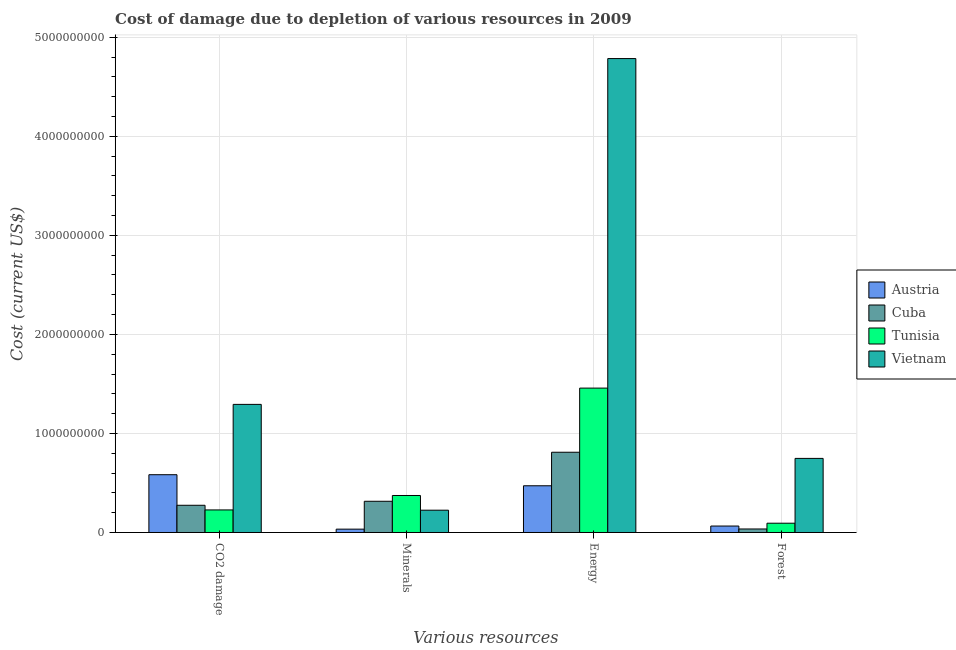How many different coloured bars are there?
Your answer should be compact. 4. Are the number of bars on each tick of the X-axis equal?
Your response must be concise. Yes. How many bars are there on the 3rd tick from the right?
Provide a short and direct response. 4. What is the label of the 3rd group of bars from the left?
Make the answer very short. Energy. What is the cost of damage due to depletion of energy in Cuba?
Your answer should be very brief. 8.10e+08. Across all countries, what is the maximum cost of damage due to depletion of energy?
Offer a terse response. 4.79e+09. Across all countries, what is the minimum cost of damage due to depletion of coal?
Your response must be concise. 2.28e+08. In which country was the cost of damage due to depletion of minerals maximum?
Provide a short and direct response. Tunisia. What is the total cost of damage due to depletion of coal in the graph?
Your response must be concise. 2.38e+09. What is the difference between the cost of damage due to depletion of energy in Cuba and that in Austria?
Make the answer very short. 3.39e+08. What is the difference between the cost of damage due to depletion of coal in Tunisia and the cost of damage due to depletion of energy in Cuba?
Offer a terse response. -5.82e+08. What is the average cost of damage due to depletion of minerals per country?
Ensure brevity in your answer.  2.37e+08. What is the difference between the cost of damage due to depletion of forests and cost of damage due to depletion of energy in Cuba?
Offer a very short reply. -7.75e+08. What is the ratio of the cost of damage due to depletion of coal in Tunisia to that in Austria?
Your answer should be compact. 0.39. Is the difference between the cost of damage due to depletion of energy in Vietnam and Tunisia greater than the difference between the cost of damage due to depletion of forests in Vietnam and Tunisia?
Ensure brevity in your answer.  Yes. What is the difference between the highest and the second highest cost of damage due to depletion of minerals?
Your answer should be very brief. 5.83e+07. What is the difference between the highest and the lowest cost of damage due to depletion of coal?
Provide a short and direct response. 1.07e+09. Is it the case that in every country, the sum of the cost of damage due to depletion of energy and cost of damage due to depletion of forests is greater than the sum of cost of damage due to depletion of minerals and cost of damage due to depletion of coal?
Ensure brevity in your answer.  No. What does the 1st bar from the left in Forest represents?
Your answer should be compact. Austria. What does the 2nd bar from the right in Energy represents?
Provide a succinct answer. Tunisia. How many bars are there?
Ensure brevity in your answer.  16. Are the values on the major ticks of Y-axis written in scientific E-notation?
Ensure brevity in your answer.  No. Does the graph contain any zero values?
Ensure brevity in your answer.  No. Does the graph contain grids?
Your answer should be compact. Yes. How many legend labels are there?
Keep it short and to the point. 4. What is the title of the graph?
Make the answer very short. Cost of damage due to depletion of various resources in 2009 . What is the label or title of the X-axis?
Provide a short and direct response. Various resources. What is the label or title of the Y-axis?
Your answer should be very brief. Cost (current US$). What is the Cost (current US$) of Austria in CO2 damage?
Make the answer very short. 5.83e+08. What is the Cost (current US$) of Cuba in CO2 damage?
Provide a succinct answer. 2.75e+08. What is the Cost (current US$) in Tunisia in CO2 damage?
Give a very brief answer. 2.28e+08. What is the Cost (current US$) of Vietnam in CO2 damage?
Keep it short and to the point. 1.29e+09. What is the Cost (current US$) of Austria in Minerals?
Make the answer very short. 3.38e+07. What is the Cost (current US$) of Cuba in Minerals?
Provide a short and direct response. 3.15e+08. What is the Cost (current US$) in Tunisia in Minerals?
Provide a succinct answer. 3.73e+08. What is the Cost (current US$) in Vietnam in Minerals?
Provide a short and direct response. 2.25e+08. What is the Cost (current US$) of Austria in Energy?
Keep it short and to the point. 4.72e+08. What is the Cost (current US$) of Cuba in Energy?
Keep it short and to the point. 8.10e+08. What is the Cost (current US$) in Tunisia in Energy?
Offer a very short reply. 1.46e+09. What is the Cost (current US$) of Vietnam in Energy?
Make the answer very short. 4.79e+09. What is the Cost (current US$) in Austria in Forest?
Offer a terse response. 6.51e+07. What is the Cost (current US$) of Cuba in Forest?
Provide a short and direct response. 3.54e+07. What is the Cost (current US$) in Tunisia in Forest?
Your answer should be very brief. 9.37e+07. What is the Cost (current US$) of Vietnam in Forest?
Provide a succinct answer. 7.48e+08. Across all Various resources, what is the maximum Cost (current US$) in Austria?
Give a very brief answer. 5.83e+08. Across all Various resources, what is the maximum Cost (current US$) in Cuba?
Your response must be concise. 8.10e+08. Across all Various resources, what is the maximum Cost (current US$) of Tunisia?
Provide a short and direct response. 1.46e+09. Across all Various resources, what is the maximum Cost (current US$) in Vietnam?
Ensure brevity in your answer.  4.79e+09. Across all Various resources, what is the minimum Cost (current US$) in Austria?
Your answer should be very brief. 3.38e+07. Across all Various resources, what is the minimum Cost (current US$) in Cuba?
Give a very brief answer. 3.54e+07. Across all Various resources, what is the minimum Cost (current US$) in Tunisia?
Offer a terse response. 9.37e+07. Across all Various resources, what is the minimum Cost (current US$) in Vietnam?
Your response must be concise. 2.25e+08. What is the total Cost (current US$) in Austria in the graph?
Your response must be concise. 1.15e+09. What is the total Cost (current US$) of Cuba in the graph?
Provide a short and direct response. 1.44e+09. What is the total Cost (current US$) of Tunisia in the graph?
Offer a terse response. 2.15e+09. What is the total Cost (current US$) of Vietnam in the graph?
Provide a short and direct response. 7.05e+09. What is the difference between the Cost (current US$) of Austria in CO2 damage and that in Minerals?
Keep it short and to the point. 5.50e+08. What is the difference between the Cost (current US$) of Cuba in CO2 damage and that in Minerals?
Provide a short and direct response. -4.05e+07. What is the difference between the Cost (current US$) in Tunisia in CO2 damage and that in Minerals?
Make the answer very short. -1.46e+08. What is the difference between the Cost (current US$) of Vietnam in CO2 damage and that in Minerals?
Your response must be concise. 1.07e+09. What is the difference between the Cost (current US$) in Austria in CO2 damage and that in Energy?
Ensure brevity in your answer.  1.12e+08. What is the difference between the Cost (current US$) of Cuba in CO2 damage and that in Energy?
Ensure brevity in your answer.  -5.35e+08. What is the difference between the Cost (current US$) in Tunisia in CO2 damage and that in Energy?
Offer a terse response. -1.23e+09. What is the difference between the Cost (current US$) in Vietnam in CO2 damage and that in Energy?
Ensure brevity in your answer.  -3.49e+09. What is the difference between the Cost (current US$) in Austria in CO2 damage and that in Forest?
Give a very brief answer. 5.18e+08. What is the difference between the Cost (current US$) of Cuba in CO2 damage and that in Forest?
Keep it short and to the point. 2.39e+08. What is the difference between the Cost (current US$) in Tunisia in CO2 damage and that in Forest?
Give a very brief answer. 1.34e+08. What is the difference between the Cost (current US$) of Vietnam in CO2 damage and that in Forest?
Make the answer very short. 5.45e+08. What is the difference between the Cost (current US$) of Austria in Minerals and that in Energy?
Ensure brevity in your answer.  -4.38e+08. What is the difference between the Cost (current US$) of Cuba in Minerals and that in Energy?
Provide a succinct answer. -4.95e+08. What is the difference between the Cost (current US$) of Tunisia in Minerals and that in Energy?
Ensure brevity in your answer.  -1.08e+09. What is the difference between the Cost (current US$) of Vietnam in Minerals and that in Energy?
Give a very brief answer. -4.56e+09. What is the difference between the Cost (current US$) in Austria in Minerals and that in Forest?
Your answer should be compact. -3.13e+07. What is the difference between the Cost (current US$) of Cuba in Minerals and that in Forest?
Make the answer very short. 2.80e+08. What is the difference between the Cost (current US$) in Tunisia in Minerals and that in Forest?
Offer a terse response. 2.80e+08. What is the difference between the Cost (current US$) in Vietnam in Minerals and that in Forest?
Offer a very short reply. -5.23e+08. What is the difference between the Cost (current US$) of Austria in Energy and that in Forest?
Your response must be concise. 4.07e+08. What is the difference between the Cost (current US$) in Cuba in Energy and that in Forest?
Offer a terse response. 7.75e+08. What is the difference between the Cost (current US$) of Tunisia in Energy and that in Forest?
Offer a terse response. 1.36e+09. What is the difference between the Cost (current US$) of Vietnam in Energy and that in Forest?
Provide a short and direct response. 4.04e+09. What is the difference between the Cost (current US$) in Austria in CO2 damage and the Cost (current US$) in Cuba in Minerals?
Give a very brief answer. 2.68e+08. What is the difference between the Cost (current US$) of Austria in CO2 damage and the Cost (current US$) of Tunisia in Minerals?
Your answer should be very brief. 2.10e+08. What is the difference between the Cost (current US$) in Austria in CO2 damage and the Cost (current US$) in Vietnam in Minerals?
Offer a terse response. 3.58e+08. What is the difference between the Cost (current US$) in Cuba in CO2 damage and the Cost (current US$) in Tunisia in Minerals?
Provide a short and direct response. -9.88e+07. What is the difference between the Cost (current US$) of Cuba in CO2 damage and the Cost (current US$) of Vietnam in Minerals?
Give a very brief answer. 4.96e+07. What is the difference between the Cost (current US$) of Tunisia in CO2 damage and the Cost (current US$) of Vietnam in Minerals?
Give a very brief answer. 2.63e+06. What is the difference between the Cost (current US$) of Austria in CO2 damage and the Cost (current US$) of Cuba in Energy?
Make the answer very short. -2.27e+08. What is the difference between the Cost (current US$) of Austria in CO2 damage and the Cost (current US$) of Tunisia in Energy?
Give a very brief answer. -8.75e+08. What is the difference between the Cost (current US$) in Austria in CO2 damage and the Cost (current US$) in Vietnam in Energy?
Your answer should be very brief. -4.20e+09. What is the difference between the Cost (current US$) of Cuba in CO2 damage and the Cost (current US$) of Tunisia in Energy?
Keep it short and to the point. -1.18e+09. What is the difference between the Cost (current US$) in Cuba in CO2 damage and the Cost (current US$) in Vietnam in Energy?
Offer a terse response. -4.51e+09. What is the difference between the Cost (current US$) of Tunisia in CO2 damage and the Cost (current US$) of Vietnam in Energy?
Your answer should be compact. -4.56e+09. What is the difference between the Cost (current US$) of Austria in CO2 damage and the Cost (current US$) of Cuba in Forest?
Your answer should be very brief. 5.48e+08. What is the difference between the Cost (current US$) in Austria in CO2 damage and the Cost (current US$) in Tunisia in Forest?
Offer a very short reply. 4.90e+08. What is the difference between the Cost (current US$) in Austria in CO2 damage and the Cost (current US$) in Vietnam in Forest?
Provide a short and direct response. -1.65e+08. What is the difference between the Cost (current US$) in Cuba in CO2 damage and the Cost (current US$) in Tunisia in Forest?
Your response must be concise. 1.81e+08. What is the difference between the Cost (current US$) of Cuba in CO2 damage and the Cost (current US$) of Vietnam in Forest?
Your answer should be very brief. -4.73e+08. What is the difference between the Cost (current US$) in Tunisia in CO2 damage and the Cost (current US$) in Vietnam in Forest?
Give a very brief answer. -5.20e+08. What is the difference between the Cost (current US$) of Austria in Minerals and the Cost (current US$) of Cuba in Energy?
Ensure brevity in your answer.  -7.76e+08. What is the difference between the Cost (current US$) in Austria in Minerals and the Cost (current US$) in Tunisia in Energy?
Offer a very short reply. -1.42e+09. What is the difference between the Cost (current US$) of Austria in Minerals and the Cost (current US$) of Vietnam in Energy?
Your response must be concise. -4.75e+09. What is the difference between the Cost (current US$) in Cuba in Minerals and the Cost (current US$) in Tunisia in Energy?
Your answer should be compact. -1.14e+09. What is the difference between the Cost (current US$) of Cuba in Minerals and the Cost (current US$) of Vietnam in Energy?
Your response must be concise. -4.47e+09. What is the difference between the Cost (current US$) of Tunisia in Minerals and the Cost (current US$) of Vietnam in Energy?
Ensure brevity in your answer.  -4.41e+09. What is the difference between the Cost (current US$) in Austria in Minerals and the Cost (current US$) in Cuba in Forest?
Your answer should be compact. -1.60e+06. What is the difference between the Cost (current US$) in Austria in Minerals and the Cost (current US$) in Tunisia in Forest?
Offer a very short reply. -5.99e+07. What is the difference between the Cost (current US$) in Austria in Minerals and the Cost (current US$) in Vietnam in Forest?
Your answer should be very brief. -7.14e+08. What is the difference between the Cost (current US$) in Cuba in Minerals and the Cost (current US$) in Tunisia in Forest?
Your answer should be very brief. 2.21e+08. What is the difference between the Cost (current US$) of Cuba in Minerals and the Cost (current US$) of Vietnam in Forest?
Provide a succinct answer. -4.33e+08. What is the difference between the Cost (current US$) of Tunisia in Minerals and the Cost (current US$) of Vietnam in Forest?
Your answer should be compact. -3.75e+08. What is the difference between the Cost (current US$) of Austria in Energy and the Cost (current US$) of Cuba in Forest?
Offer a terse response. 4.36e+08. What is the difference between the Cost (current US$) of Austria in Energy and the Cost (current US$) of Tunisia in Forest?
Give a very brief answer. 3.78e+08. What is the difference between the Cost (current US$) of Austria in Energy and the Cost (current US$) of Vietnam in Forest?
Give a very brief answer. -2.76e+08. What is the difference between the Cost (current US$) of Cuba in Energy and the Cost (current US$) of Tunisia in Forest?
Provide a succinct answer. 7.16e+08. What is the difference between the Cost (current US$) of Cuba in Energy and the Cost (current US$) of Vietnam in Forest?
Provide a succinct answer. 6.21e+07. What is the difference between the Cost (current US$) in Tunisia in Energy and the Cost (current US$) in Vietnam in Forest?
Provide a short and direct response. 7.10e+08. What is the average Cost (current US$) of Austria per Various resources?
Provide a short and direct response. 2.88e+08. What is the average Cost (current US$) of Cuba per Various resources?
Your response must be concise. 3.59e+08. What is the average Cost (current US$) of Tunisia per Various resources?
Make the answer very short. 5.38e+08. What is the average Cost (current US$) in Vietnam per Various resources?
Offer a terse response. 1.76e+09. What is the difference between the Cost (current US$) of Austria and Cost (current US$) of Cuba in CO2 damage?
Give a very brief answer. 3.09e+08. What is the difference between the Cost (current US$) in Austria and Cost (current US$) in Tunisia in CO2 damage?
Offer a very short reply. 3.56e+08. What is the difference between the Cost (current US$) in Austria and Cost (current US$) in Vietnam in CO2 damage?
Your response must be concise. -7.10e+08. What is the difference between the Cost (current US$) in Cuba and Cost (current US$) in Tunisia in CO2 damage?
Keep it short and to the point. 4.70e+07. What is the difference between the Cost (current US$) in Cuba and Cost (current US$) in Vietnam in CO2 damage?
Your response must be concise. -1.02e+09. What is the difference between the Cost (current US$) in Tunisia and Cost (current US$) in Vietnam in CO2 damage?
Give a very brief answer. -1.07e+09. What is the difference between the Cost (current US$) in Austria and Cost (current US$) in Cuba in Minerals?
Your answer should be very brief. -2.81e+08. What is the difference between the Cost (current US$) of Austria and Cost (current US$) of Tunisia in Minerals?
Offer a very short reply. -3.40e+08. What is the difference between the Cost (current US$) in Austria and Cost (current US$) in Vietnam in Minerals?
Keep it short and to the point. -1.91e+08. What is the difference between the Cost (current US$) in Cuba and Cost (current US$) in Tunisia in Minerals?
Offer a terse response. -5.83e+07. What is the difference between the Cost (current US$) in Cuba and Cost (current US$) in Vietnam in Minerals?
Your answer should be very brief. 9.01e+07. What is the difference between the Cost (current US$) of Tunisia and Cost (current US$) of Vietnam in Minerals?
Your response must be concise. 1.48e+08. What is the difference between the Cost (current US$) of Austria and Cost (current US$) of Cuba in Energy?
Provide a short and direct response. -3.39e+08. What is the difference between the Cost (current US$) in Austria and Cost (current US$) in Tunisia in Energy?
Your response must be concise. -9.86e+08. What is the difference between the Cost (current US$) of Austria and Cost (current US$) of Vietnam in Energy?
Ensure brevity in your answer.  -4.31e+09. What is the difference between the Cost (current US$) in Cuba and Cost (current US$) in Tunisia in Energy?
Ensure brevity in your answer.  -6.48e+08. What is the difference between the Cost (current US$) of Cuba and Cost (current US$) of Vietnam in Energy?
Offer a terse response. -3.97e+09. What is the difference between the Cost (current US$) of Tunisia and Cost (current US$) of Vietnam in Energy?
Make the answer very short. -3.33e+09. What is the difference between the Cost (current US$) in Austria and Cost (current US$) in Cuba in Forest?
Offer a very short reply. 2.97e+07. What is the difference between the Cost (current US$) in Austria and Cost (current US$) in Tunisia in Forest?
Make the answer very short. -2.86e+07. What is the difference between the Cost (current US$) in Austria and Cost (current US$) in Vietnam in Forest?
Keep it short and to the point. -6.83e+08. What is the difference between the Cost (current US$) in Cuba and Cost (current US$) in Tunisia in Forest?
Give a very brief answer. -5.83e+07. What is the difference between the Cost (current US$) of Cuba and Cost (current US$) of Vietnam in Forest?
Your response must be concise. -7.13e+08. What is the difference between the Cost (current US$) in Tunisia and Cost (current US$) in Vietnam in Forest?
Make the answer very short. -6.54e+08. What is the ratio of the Cost (current US$) of Austria in CO2 damage to that in Minerals?
Give a very brief answer. 17.27. What is the ratio of the Cost (current US$) of Cuba in CO2 damage to that in Minerals?
Ensure brevity in your answer.  0.87. What is the ratio of the Cost (current US$) in Tunisia in CO2 damage to that in Minerals?
Offer a terse response. 0.61. What is the ratio of the Cost (current US$) of Vietnam in CO2 damage to that in Minerals?
Your answer should be very brief. 5.75. What is the ratio of the Cost (current US$) in Austria in CO2 damage to that in Energy?
Offer a terse response. 1.24. What is the ratio of the Cost (current US$) in Cuba in CO2 damage to that in Energy?
Provide a succinct answer. 0.34. What is the ratio of the Cost (current US$) of Tunisia in CO2 damage to that in Energy?
Offer a very short reply. 0.16. What is the ratio of the Cost (current US$) in Vietnam in CO2 damage to that in Energy?
Provide a succinct answer. 0.27. What is the ratio of the Cost (current US$) in Austria in CO2 damage to that in Forest?
Give a very brief answer. 8.96. What is the ratio of the Cost (current US$) in Cuba in CO2 damage to that in Forest?
Provide a succinct answer. 7.77. What is the ratio of the Cost (current US$) of Tunisia in CO2 damage to that in Forest?
Your response must be concise. 2.43. What is the ratio of the Cost (current US$) of Vietnam in CO2 damage to that in Forest?
Ensure brevity in your answer.  1.73. What is the ratio of the Cost (current US$) in Austria in Minerals to that in Energy?
Offer a terse response. 0.07. What is the ratio of the Cost (current US$) of Cuba in Minerals to that in Energy?
Your answer should be compact. 0.39. What is the ratio of the Cost (current US$) of Tunisia in Minerals to that in Energy?
Ensure brevity in your answer.  0.26. What is the ratio of the Cost (current US$) of Vietnam in Minerals to that in Energy?
Provide a succinct answer. 0.05. What is the ratio of the Cost (current US$) of Austria in Minerals to that in Forest?
Make the answer very short. 0.52. What is the ratio of the Cost (current US$) in Cuba in Minerals to that in Forest?
Make the answer very short. 8.91. What is the ratio of the Cost (current US$) in Tunisia in Minerals to that in Forest?
Give a very brief answer. 3.99. What is the ratio of the Cost (current US$) of Vietnam in Minerals to that in Forest?
Give a very brief answer. 0.3. What is the ratio of the Cost (current US$) in Austria in Energy to that in Forest?
Keep it short and to the point. 7.25. What is the ratio of the Cost (current US$) of Cuba in Energy to that in Forest?
Provide a short and direct response. 22.91. What is the ratio of the Cost (current US$) of Tunisia in Energy to that in Forest?
Offer a very short reply. 15.56. What is the ratio of the Cost (current US$) of Vietnam in Energy to that in Forest?
Ensure brevity in your answer.  6.4. What is the difference between the highest and the second highest Cost (current US$) of Austria?
Keep it short and to the point. 1.12e+08. What is the difference between the highest and the second highest Cost (current US$) in Cuba?
Offer a terse response. 4.95e+08. What is the difference between the highest and the second highest Cost (current US$) in Tunisia?
Keep it short and to the point. 1.08e+09. What is the difference between the highest and the second highest Cost (current US$) of Vietnam?
Your response must be concise. 3.49e+09. What is the difference between the highest and the lowest Cost (current US$) in Austria?
Keep it short and to the point. 5.50e+08. What is the difference between the highest and the lowest Cost (current US$) in Cuba?
Offer a very short reply. 7.75e+08. What is the difference between the highest and the lowest Cost (current US$) of Tunisia?
Your response must be concise. 1.36e+09. What is the difference between the highest and the lowest Cost (current US$) of Vietnam?
Make the answer very short. 4.56e+09. 